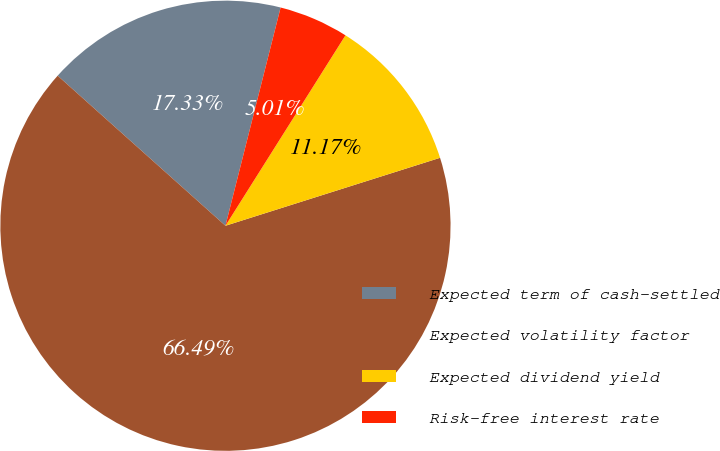<chart> <loc_0><loc_0><loc_500><loc_500><pie_chart><fcel>Expected term of cash-settled<fcel>Expected volatility factor<fcel>Expected dividend yield<fcel>Risk-free interest rate<nl><fcel>17.33%<fcel>66.5%<fcel>11.17%<fcel>5.01%<nl></chart> 